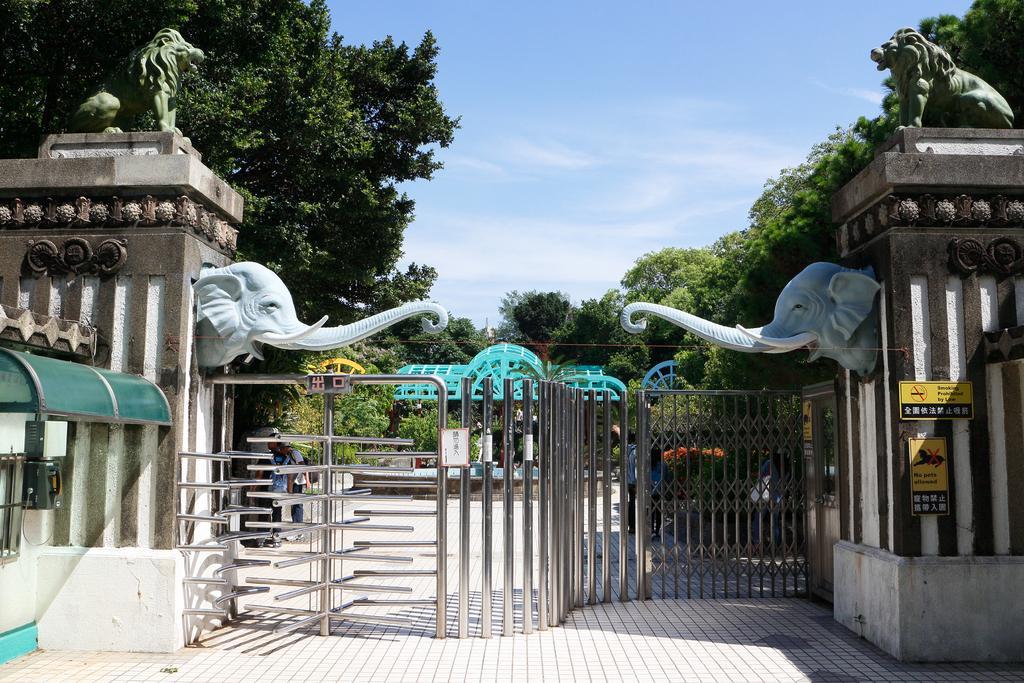Describe this image in one or two sentences. In this picture we can able to see a gate, there are two elephant sculptures, on top it we can able to two lion sculptures, we can able to see few trees, we can see two sign boards, and also we can see a telephone, and there is a rooftop over it, and we can able to see a sky. 